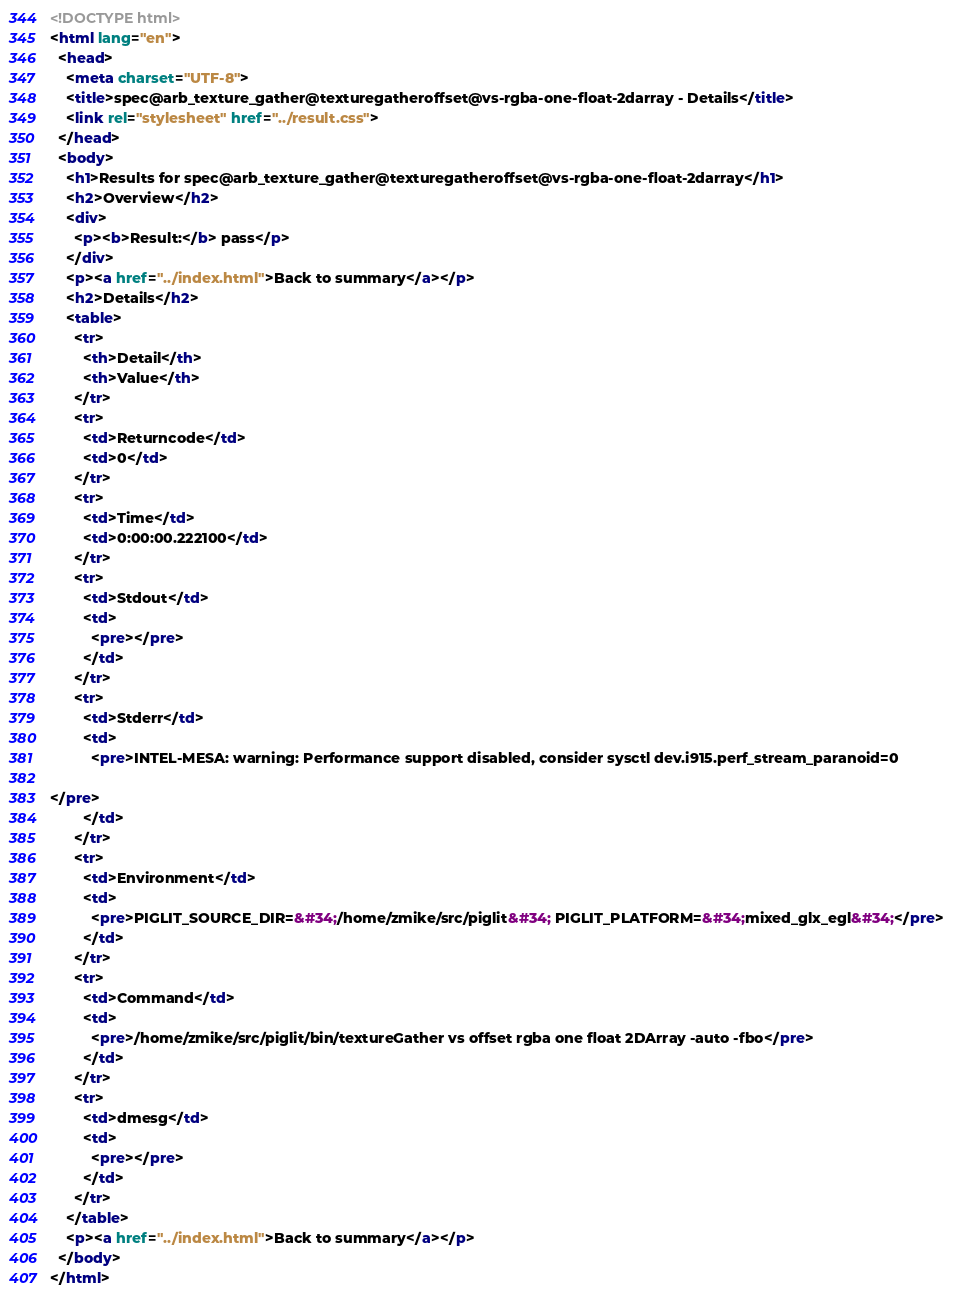<code> <loc_0><loc_0><loc_500><loc_500><_HTML_><!DOCTYPE html>
<html lang="en">
  <head>
    <meta charset="UTF-8">
    <title>spec@arb_texture_gather@texturegatheroffset@vs-rgba-one-float-2darray - Details</title>
    <link rel="stylesheet" href="../result.css">
  </head>
  <body>
    <h1>Results for spec@arb_texture_gather@texturegatheroffset@vs-rgba-one-float-2darray</h1>
    <h2>Overview</h2>
    <div>
      <p><b>Result:</b> pass</p>
    </div>
    <p><a href="../index.html">Back to summary</a></p>
    <h2>Details</h2>
    <table>
      <tr>
        <th>Detail</th>
        <th>Value</th>
      </tr>
      <tr>
        <td>Returncode</td>
        <td>0</td>
      </tr>
      <tr>
        <td>Time</td>
        <td>0:00:00.222100</td>
      </tr>
      <tr>
        <td>Stdout</td>
        <td>
          <pre></pre>
        </td>
      </tr>
      <tr>
        <td>Stderr</td>
        <td>
          <pre>INTEL-MESA: warning: Performance support disabled, consider sysctl dev.i915.perf_stream_paranoid=0

</pre>
        </td>
      </tr>
      <tr>
        <td>Environment</td>
        <td>
          <pre>PIGLIT_SOURCE_DIR=&#34;/home/zmike/src/piglit&#34; PIGLIT_PLATFORM=&#34;mixed_glx_egl&#34;</pre>
        </td>
      </tr>
      <tr>
        <td>Command</td>
        <td>
          <pre>/home/zmike/src/piglit/bin/textureGather vs offset rgba one float 2DArray -auto -fbo</pre>
        </td>
      </tr>
      <tr>
        <td>dmesg</td>
        <td>
          <pre></pre>
        </td>
      </tr>
    </table>
    <p><a href="../index.html">Back to summary</a></p>
  </body>
</html>
</code> 